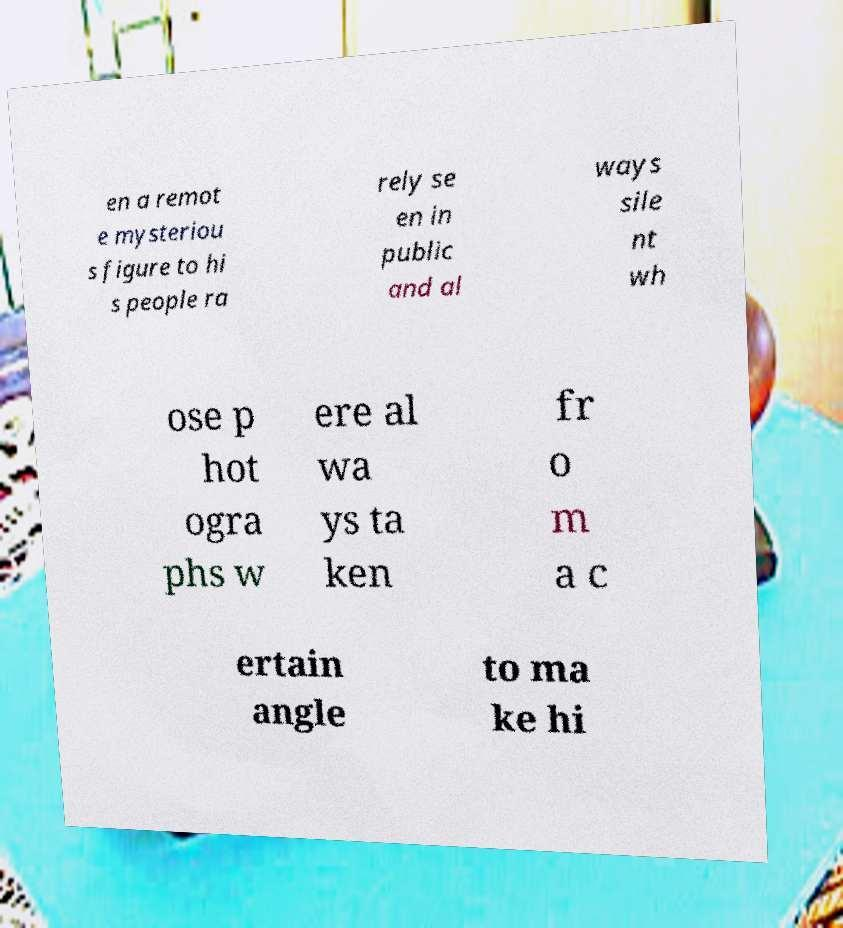Please identify and transcribe the text found in this image. en a remot e mysteriou s figure to hi s people ra rely se en in public and al ways sile nt wh ose p hot ogra phs w ere al wa ys ta ken fr o m a c ertain angle to ma ke hi 